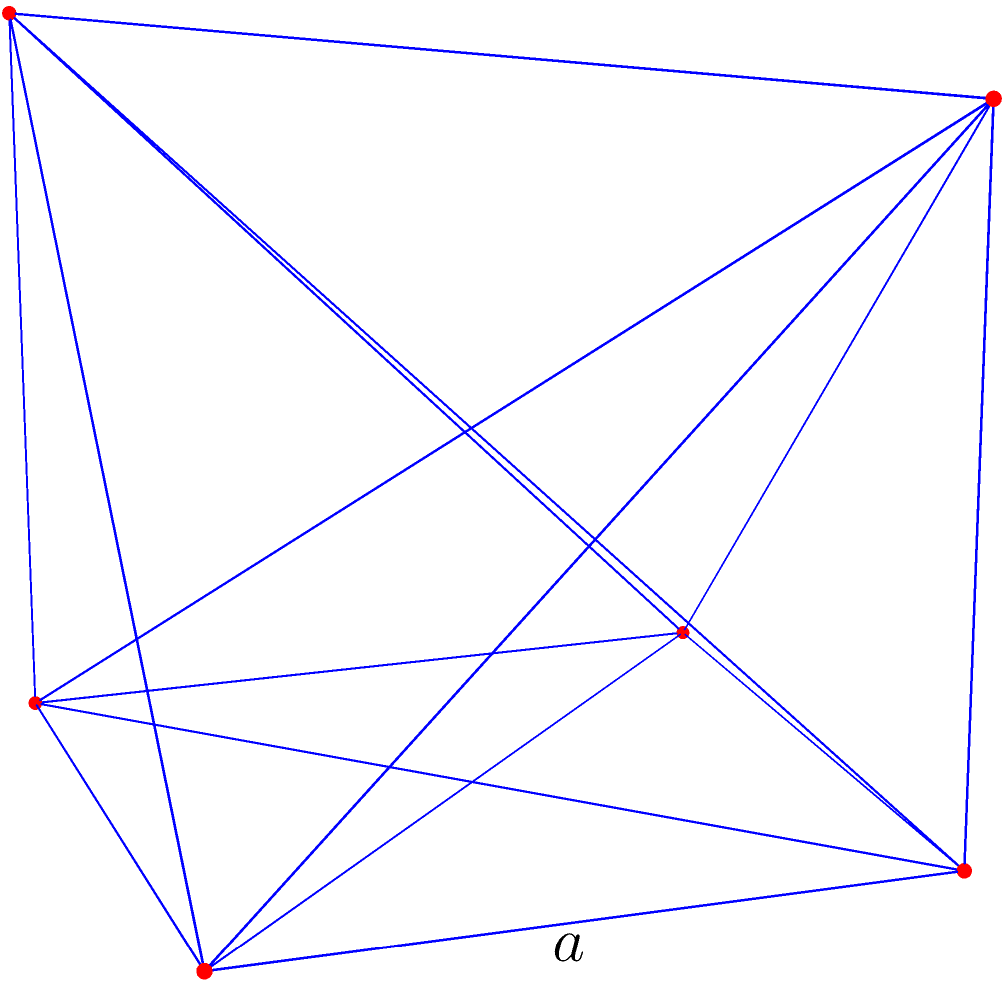Как специалист в области информационных технологий, вы разрабатываете программу для 3D-моделирования. Вам необходимо вычислить площадь поверхности правильного октаэдра для оптимизации рендеринга. Если длина ребра октаэдра равна $a$, определите формулу для расчета площади его поверхности. Для решения этой задачи выполним следующие шаги:

1) Правильный октаэдр состоит из 8 равносторонних треугольников.

2) Площадь поверхности октаэдра - это сумма площадей всех этих треугольников.

3) Площадь одного равностороннего треугольника со стороной $a$ вычисляется по формуле:
   $$A_{\text{треугольника}} = \frac{\sqrt{3}}{4}a^2$$

4) Так как октаэдр состоит из 8 таких треугольников, общая площадь поверхности будет:
   $$A_{\text{октаэдра}} = 8 \cdot \frac{\sqrt{3}}{4}a^2 = 2\sqrt{3}a^2$$

5) Упростим формулу:
   $$A_{\text{октаэдра}} = 2\sqrt{3}a^2$$

Эта формула позволяет быстро вычислить площадь поверхности октаэдра, зная только длину его ребра, что может быть полезно для оптимизации алгоритмов рендеринга в 3D-графике.
Answer: $2\sqrt{3}a^2$ 